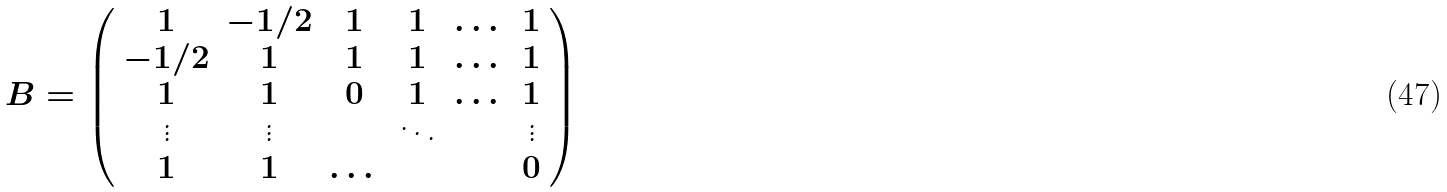Convert formula to latex. <formula><loc_0><loc_0><loc_500><loc_500>B = \left ( \begin{array} { c c c c c c } 1 & - 1 / 2 & 1 & 1 & \dots & 1 \\ - 1 / 2 & 1 & 1 & 1 & \dots & 1 \\ 1 & 1 & 0 & 1 & \dots & 1 \\ \vdots & \vdots & & \ddots & & \vdots \\ 1 & 1 & \dots & & & 0 \end{array} \right )</formula> 